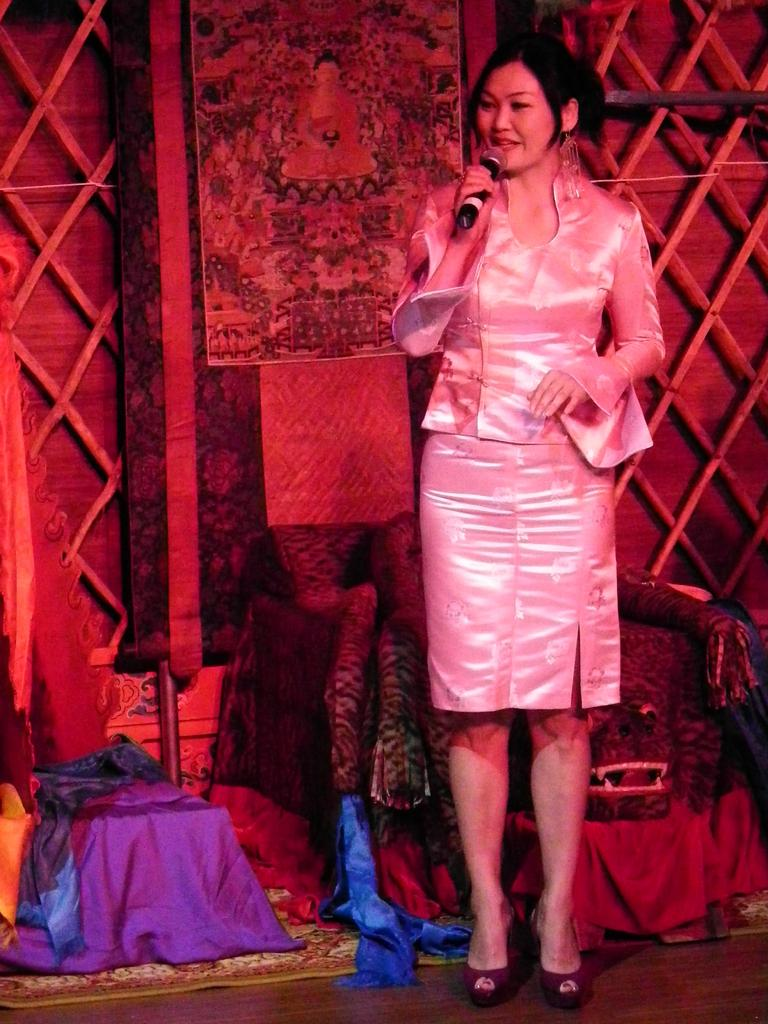Who is the main subject in the image? There is a lady in the image. What is the lady doing in the image? The lady is standing on the floor and holding a microphone. What else can be seen in the image besides the lady? There are clothes in front of a wall in the image. What type of match is being played in the image? There is no match being played in the image; it features a lady standing on the floor and holding a microphone, along with clothes in front of a wall. 